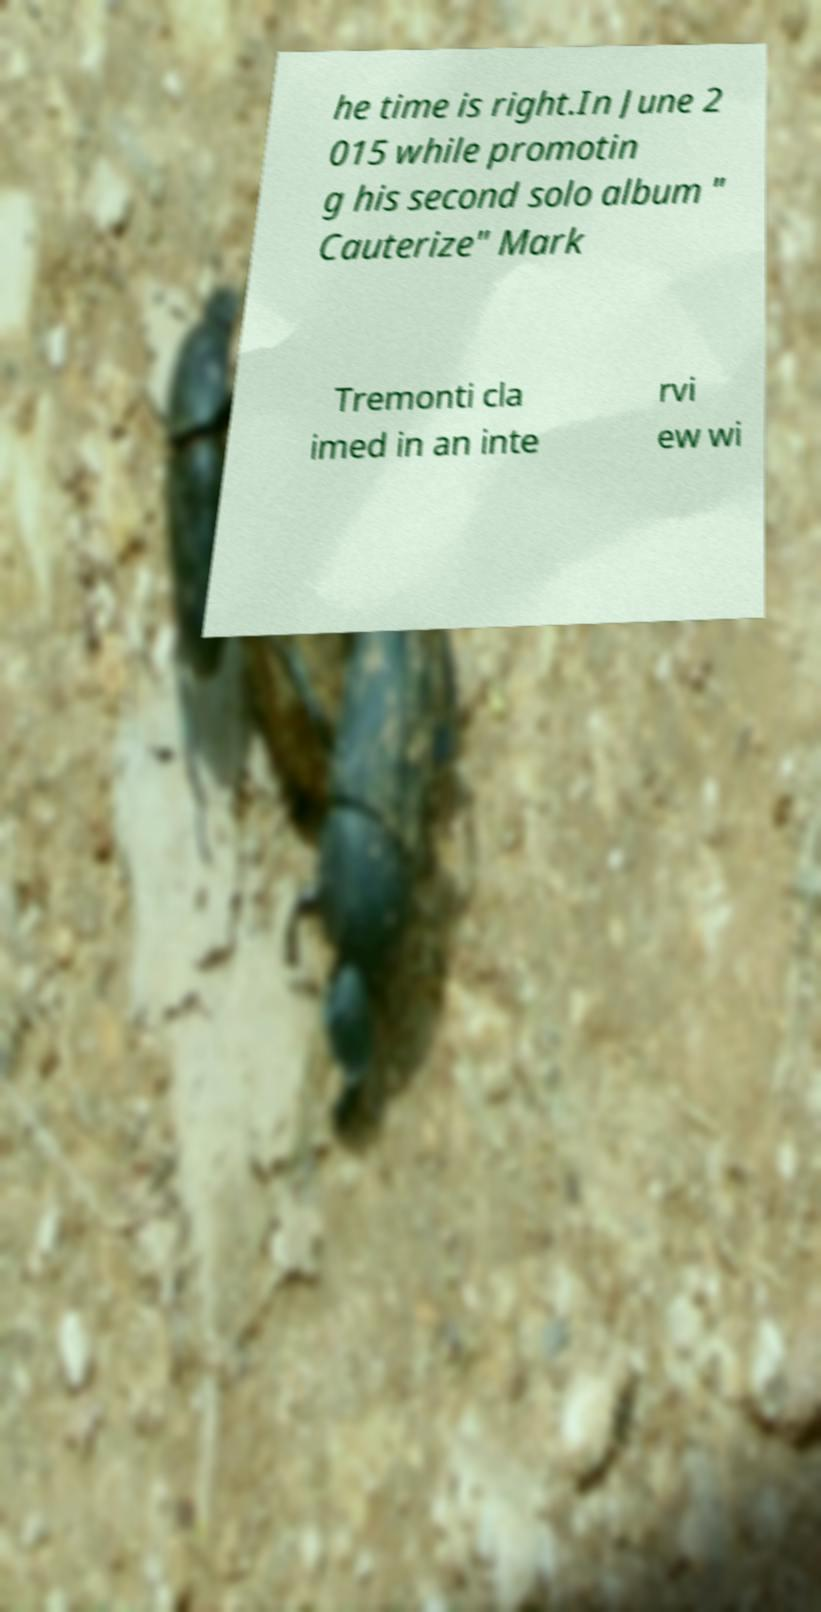Can you read and provide the text displayed in the image?This photo seems to have some interesting text. Can you extract and type it out for me? he time is right.In June 2 015 while promotin g his second solo album " Cauterize" Mark Tremonti cla imed in an inte rvi ew wi 